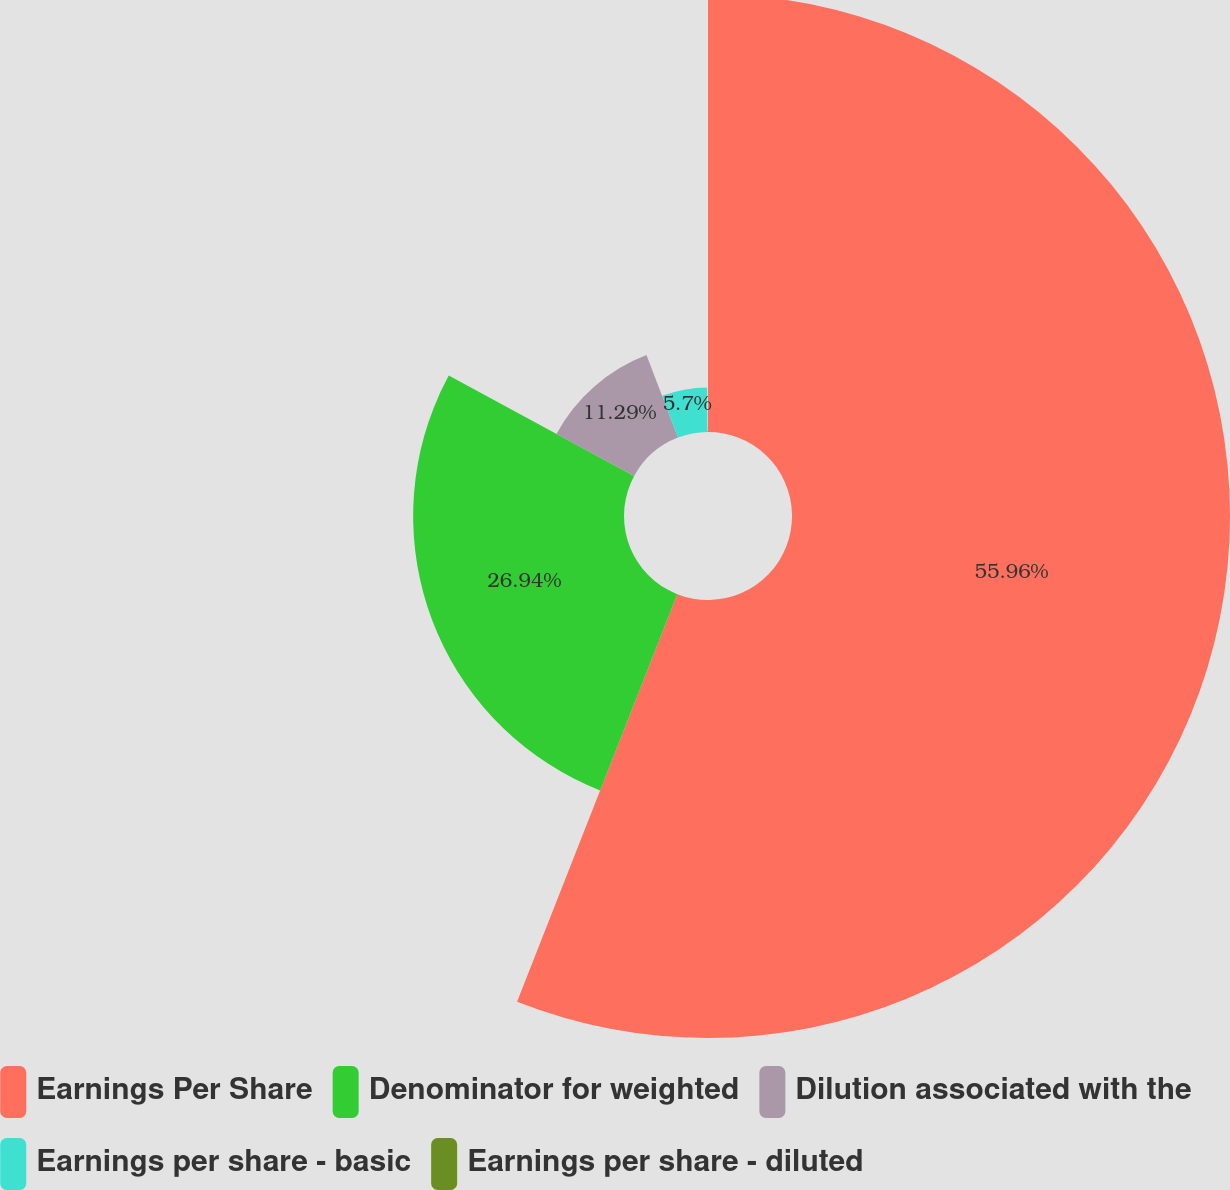Convert chart. <chart><loc_0><loc_0><loc_500><loc_500><pie_chart><fcel>Earnings Per Share<fcel>Denominator for weighted<fcel>Dilution associated with the<fcel>Earnings per share - basic<fcel>Earnings per share - diluted<nl><fcel>55.96%<fcel>26.94%<fcel>11.29%<fcel>5.7%<fcel>0.11%<nl></chart> 